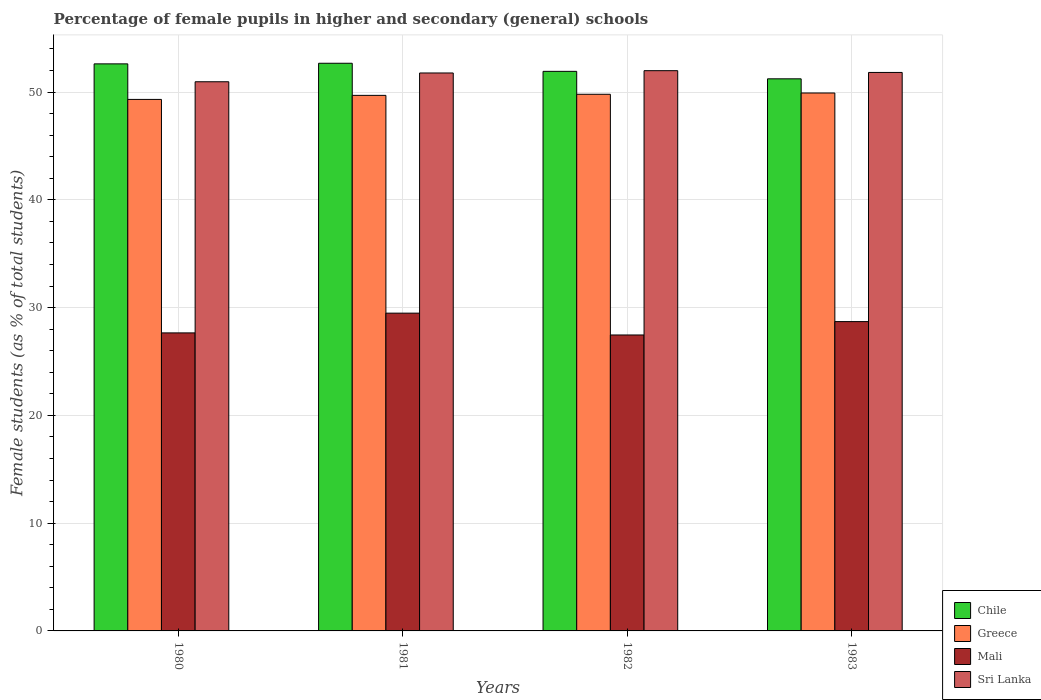How many groups of bars are there?
Ensure brevity in your answer.  4. Are the number of bars per tick equal to the number of legend labels?
Give a very brief answer. Yes. How many bars are there on the 1st tick from the left?
Offer a very short reply. 4. What is the percentage of female pupils in higher and secondary schools in Chile in 1980?
Offer a very short reply. 52.62. Across all years, what is the maximum percentage of female pupils in higher and secondary schools in Mali?
Your answer should be compact. 29.49. Across all years, what is the minimum percentage of female pupils in higher and secondary schools in Mali?
Provide a short and direct response. 27.46. In which year was the percentage of female pupils in higher and secondary schools in Sri Lanka minimum?
Your response must be concise. 1980. What is the total percentage of female pupils in higher and secondary schools in Greece in the graph?
Provide a succinct answer. 198.72. What is the difference between the percentage of female pupils in higher and secondary schools in Chile in 1981 and that in 1983?
Provide a short and direct response. 1.44. What is the difference between the percentage of female pupils in higher and secondary schools in Sri Lanka in 1981 and the percentage of female pupils in higher and secondary schools in Mali in 1980?
Your answer should be compact. 24.12. What is the average percentage of female pupils in higher and secondary schools in Chile per year?
Make the answer very short. 52.11. In the year 1983, what is the difference between the percentage of female pupils in higher and secondary schools in Mali and percentage of female pupils in higher and secondary schools in Sri Lanka?
Give a very brief answer. -23.12. What is the ratio of the percentage of female pupils in higher and secondary schools in Sri Lanka in 1981 to that in 1983?
Provide a succinct answer. 1. Is the percentage of female pupils in higher and secondary schools in Chile in 1982 less than that in 1983?
Your answer should be compact. No. Is the difference between the percentage of female pupils in higher and secondary schools in Mali in 1980 and 1983 greater than the difference between the percentage of female pupils in higher and secondary schools in Sri Lanka in 1980 and 1983?
Offer a very short reply. No. What is the difference between the highest and the second highest percentage of female pupils in higher and secondary schools in Sri Lanka?
Provide a short and direct response. 0.16. What is the difference between the highest and the lowest percentage of female pupils in higher and secondary schools in Sri Lanka?
Provide a succinct answer. 1.03. In how many years, is the percentage of female pupils in higher and secondary schools in Greece greater than the average percentage of female pupils in higher and secondary schools in Greece taken over all years?
Provide a short and direct response. 3. Is the sum of the percentage of female pupils in higher and secondary schools in Sri Lanka in 1981 and 1982 greater than the maximum percentage of female pupils in higher and secondary schools in Chile across all years?
Your answer should be very brief. Yes. Is it the case that in every year, the sum of the percentage of female pupils in higher and secondary schools in Sri Lanka and percentage of female pupils in higher and secondary schools in Greece is greater than the sum of percentage of female pupils in higher and secondary schools in Mali and percentage of female pupils in higher and secondary schools in Chile?
Provide a succinct answer. No. What does the 2nd bar from the left in 1983 represents?
Make the answer very short. Greece. What does the 2nd bar from the right in 1982 represents?
Keep it short and to the point. Mali. Is it the case that in every year, the sum of the percentage of female pupils in higher and secondary schools in Chile and percentage of female pupils in higher and secondary schools in Mali is greater than the percentage of female pupils in higher and secondary schools in Sri Lanka?
Your response must be concise. Yes. Are all the bars in the graph horizontal?
Make the answer very short. No. How many years are there in the graph?
Make the answer very short. 4. Where does the legend appear in the graph?
Your answer should be compact. Bottom right. How are the legend labels stacked?
Make the answer very short. Vertical. What is the title of the graph?
Ensure brevity in your answer.  Percentage of female pupils in higher and secondary (general) schools. Does "High income" appear as one of the legend labels in the graph?
Provide a succinct answer. No. What is the label or title of the X-axis?
Your answer should be very brief. Years. What is the label or title of the Y-axis?
Ensure brevity in your answer.  Female students (as % of total students). What is the Female students (as % of total students) of Chile in 1980?
Offer a very short reply. 52.62. What is the Female students (as % of total students) in Greece in 1980?
Your answer should be very brief. 49.32. What is the Female students (as % of total students) in Mali in 1980?
Provide a succinct answer. 27.65. What is the Female students (as % of total students) in Sri Lanka in 1980?
Offer a very short reply. 50.96. What is the Female students (as % of total students) in Chile in 1981?
Ensure brevity in your answer.  52.67. What is the Female students (as % of total students) of Greece in 1981?
Ensure brevity in your answer.  49.69. What is the Female students (as % of total students) of Mali in 1981?
Your answer should be very brief. 29.49. What is the Female students (as % of total students) of Sri Lanka in 1981?
Offer a very short reply. 51.77. What is the Female students (as % of total students) in Chile in 1982?
Provide a succinct answer. 51.92. What is the Female students (as % of total students) in Greece in 1982?
Offer a very short reply. 49.8. What is the Female students (as % of total students) in Mali in 1982?
Keep it short and to the point. 27.46. What is the Female students (as % of total students) of Sri Lanka in 1982?
Offer a very short reply. 51.98. What is the Female students (as % of total students) in Chile in 1983?
Keep it short and to the point. 51.23. What is the Female students (as % of total students) in Greece in 1983?
Offer a very short reply. 49.91. What is the Female students (as % of total students) of Mali in 1983?
Offer a very short reply. 28.7. What is the Female students (as % of total students) of Sri Lanka in 1983?
Provide a short and direct response. 51.82. Across all years, what is the maximum Female students (as % of total students) of Chile?
Ensure brevity in your answer.  52.67. Across all years, what is the maximum Female students (as % of total students) in Greece?
Keep it short and to the point. 49.91. Across all years, what is the maximum Female students (as % of total students) in Mali?
Your answer should be compact. 29.49. Across all years, what is the maximum Female students (as % of total students) in Sri Lanka?
Offer a very short reply. 51.98. Across all years, what is the minimum Female students (as % of total students) of Chile?
Provide a short and direct response. 51.23. Across all years, what is the minimum Female students (as % of total students) of Greece?
Your response must be concise. 49.32. Across all years, what is the minimum Female students (as % of total students) in Mali?
Ensure brevity in your answer.  27.46. Across all years, what is the minimum Female students (as % of total students) in Sri Lanka?
Make the answer very short. 50.96. What is the total Female students (as % of total students) in Chile in the graph?
Keep it short and to the point. 208.44. What is the total Female students (as % of total students) in Greece in the graph?
Provide a short and direct response. 198.72. What is the total Female students (as % of total students) of Mali in the graph?
Your answer should be compact. 113.3. What is the total Female students (as % of total students) in Sri Lanka in the graph?
Keep it short and to the point. 206.53. What is the difference between the Female students (as % of total students) of Chile in 1980 and that in 1981?
Your response must be concise. -0.06. What is the difference between the Female students (as % of total students) in Greece in 1980 and that in 1981?
Your answer should be compact. -0.38. What is the difference between the Female students (as % of total students) in Mali in 1980 and that in 1981?
Your answer should be very brief. -1.83. What is the difference between the Female students (as % of total students) in Sri Lanka in 1980 and that in 1981?
Keep it short and to the point. -0.81. What is the difference between the Female students (as % of total students) in Chile in 1980 and that in 1982?
Offer a terse response. 0.69. What is the difference between the Female students (as % of total students) in Greece in 1980 and that in 1982?
Offer a terse response. -0.48. What is the difference between the Female students (as % of total students) in Mali in 1980 and that in 1982?
Provide a short and direct response. 0.19. What is the difference between the Female students (as % of total students) of Sri Lanka in 1980 and that in 1982?
Your answer should be very brief. -1.03. What is the difference between the Female students (as % of total students) in Chile in 1980 and that in 1983?
Your answer should be compact. 1.39. What is the difference between the Female students (as % of total students) of Greece in 1980 and that in 1983?
Provide a succinct answer. -0.6. What is the difference between the Female students (as % of total students) in Mali in 1980 and that in 1983?
Ensure brevity in your answer.  -1.05. What is the difference between the Female students (as % of total students) in Sri Lanka in 1980 and that in 1983?
Keep it short and to the point. -0.86. What is the difference between the Female students (as % of total students) of Chile in 1981 and that in 1982?
Give a very brief answer. 0.75. What is the difference between the Female students (as % of total students) in Greece in 1981 and that in 1982?
Offer a very short reply. -0.1. What is the difference between the Female students (as % of total students) in Mali in 1981 and that in 1982?
Provide a short and direct response. 2.03. What is the difference between the Female students (as % of total students) in Sri Lanka in 1981 and that in 1982?
Offer a very short reply. -0.21. What is the difference between the Female students (as % of total students) of Chile in 1981 and that in 1983?
Offer a very short reply. 1.44. What is the difference between the Female students (as % of total students) of Greece in 1981 and that in 1983?
Make the answer very short. -0.22. What is the difference between the Female students (as % of total students) in Mali in 1981 and that in 1983?
Provide a short and direct response. 0.78. What is the difference between the Female students (as % of total students) in Sri Lanka in 1981 and that in 1983?
Provide a succinct answer. -0.05. What is the difference between the Female students (as % of total students) in Chile in 1982 and that in 1983?
Your answer should be very brief. 0.69. What is the difference between the Female students (as % of total students) of Greece in 1982 and that in 1983?
Provide a short and direct response. -0.12. What is the difference between the Female students (as % of total students) of Mali in 1982 and that in 1983?
Offer a very short reply. -1.24. What is the difference between the Female students (as % of total students) in Sri Lanka in 1982 and that in 1983?
Your answer should be very brief. 0.16. What is the difference between the Female students (as % of total students) of Chile in 1980 and the Female students (as % of total students) of Greece in 1981?
Your response must be concise. 2.92. What is the difference between the Female students (as % of total students) in Chile in 1980 and the Female students (as % of total students) in Mali in 1981?
Offer a terse response. 23.13. What is the difference between the Female students (as % of total students) of Chile in 1980 and the Female students (as % of total students) of Sri Lanka in 1981?
Your response must be concise. 0.85. What is the difference between the Female students (as % of total students) of Greece in 1980 and the Female students (as % of total students) of Mali in 1981?
Provide a short and direct response. 19.83. What is the difference between the Female students (as % of total students) of Greece in 1980 and the Female students (as % of total students) of Sri Lanka in 1981?
Ensure brevity in your answer.  -2.45. What is the difference between the Female students (as % of total students) in Mali in 1980 and the Female students (as % of total students) in Sri Lanka in 1981?
Your answer should be compact. -24.12. What is the difference between the Female students (as % of total students) of Chile in 1980 and the Female students (as % of total students) of Greece in 1982?
Provide a short and direct response. 2.82. What is the difference between the Female students (as % of total students) of Chile in 1980 and the Female students (as % of total students) of Mali in 1982?
Provide a succinct answer. 25.16. What is the difference between the Female students (as % of total students) in Chile in 1980 and the Female students (as % of total students) in Sri Lanka in 1982?
Give a very brief answer. 0.63. What is the difference between the Female students (as % of total students) of Greece in 1980 and the Female students (as % of total students) of Mali in 1982?
Keep it short and to the point. 21.86. What is the difference between the Female students (as % of total students) of Greece in 1980 and the Female students (as % of total students) of Sri Lanka in 1982?
Ensure brevity in your answer.  -2.67. What is the difference between the Female students (as % of total students) in Mali in 1980 and the Female students (as % of total students) in Sri Lanka in 1982?
Give a very brief answer. -24.33. What is the difference between the Female students (as % of total students) in Chile in 1980 and the Female students (as % of total students) in Greece in 1983?
Provide a succinct answer. 2.7. What is the difference between the Female students (as % of total students) of Chile in 1980 and the Female students (as % of total students) of Mali in 1983?
Your answer should be very brief. 23.91. What is the difference between the Female students (as % of total students) in Chile in 1980 and the Female students (as % of total students) in Sri Lanka in 1983?
Your response must be concise. 0.8. What is the difference between the Female students (as % of total students) in Greece in 1980 and the Female students (as % of total students) in Mali in 1983?
Make the answer very short. 20.62. What is the difference between the Female students (as % of total students) of Greece in 1980 and the Female students (as % of total students) of Sri Lanka in 1983?
Provide a short and direct response. -2.5. What is the difference between the Female students (as % of total students) in Mali in 1980 and the Female students (as % of total students) in Sri Lanka in 1983?
Your answer should be very brief. -24.17. What is the difference between the Female students (as % of total students) of Chile in 1981 and the Female students (as % of total students) of Greece in 1982?
Give a very brief answer. 2.88. What is the difference between the Female students (as % of total students) in Chile in 1981 and the Female students (as % of total students) in Mali in 1982?
Give a very brief answer. 25.21. What is the difference between the Female students (as % of total students) in Chile in 1981 and the Female students (as % of total students) in Sri Lanka in 1982?
Give a very brief answer. 0.69. What is the difference between the Female students (as % of total students) of Greece in 1981 and the Female students (as % of total students) of Mali in 1982?
Your answer should be very brief. 22.23. What is the difference between the Female students (as % of total students) of Greece in 1981 and the Female students (as % of total students) of Sri Lanka in 1982?
Keep it short and to the point. -2.29. What is the difference between the Female students (as % of total students) in Mali in 1981 and the Female students (as % of total students) in Sri Lanka in 1982?
Your answer should be very brief. -22.5. What is the difference between the Female students (as % of total students) of Chile in 1981 and the Female students (as % of total students) of Greece in 1983?
Provide a short and direct response. 2.76. What is the difference between the Female students (as % of total students) in Chile in 1981 and the Female students (as % of total students) in Mali in 1983?
Make the answer very short. 23.97. What is the difference between the Female students (as % of total students) in Chile in 1981 and the Female students (as % of total students) in Sri Lanka in 1983?
Give a very brief answer. 0.85. What is the difference between the Female students (as % of total students) of Greece in 1981 and the Female students (as % of total students) of Mali in 1983?
Your answer should be very brief. 20.99. What is the difference between the Female students (as % of total students) of Greece in 1981 and the Female students (as % of total students) of Sri Lanka in 1983?
Keep it short and to the point. -2.13. What is the difference between the Female students (as % of total students) of Mali in 1981 and the Female students (as % of total students) of Sri Lanka in 1983?
Make the answer very short. -22.34. What is the difference between the Female students (as % of total students) of Chile in 1982 and the Female students (as % of total students) of Greece in 1983?
Offer a terse response. 2.01. What is the difference between the Female students (as % of total students) in Chile in 1982 and the Female students (as % of total students) in Mali in 1983?
Ensure brevity in your answer.  23.22. What is the difference between the Female students (as % of total students) in Chile in 1982 and the Female students (as % of total students) in Sri Lanka in 1983?
Make the answer very short. 0.1. What is the difference between the Female students (as % of total students) in Greece in 1982 and the Female students (as % of total students) in Mali in 1983?
Give a very brief answer. 21.09. What is the difference between the Female students (as % of total students) in Greece in 1982 and the Female students (as % of total students) in Sri Lanka in 1983?
Provide a short and direct response. -2.03. What is the difference between the Female students (as % of total students) in Mali in 1982 and the Female students (as % of total students) in Sri Lanka in 1983?
Ensure brevity in your answer.  -24.36. What is the average Female students (as % of total students) of Chile per year?
Your response must be concise. 52.11. What is the average Female students (as % of total students) in Greece per year?
Provide a succinct answer. 49.68. What is the average Female students (as % of total students) of Mali per year?
Offer a terse response. 28.33. What is the average Female students (as % of total students) of Sri Lanka per year?
Your answer should be very brief. 51.63. In the year 1980, what is the difference between the Female students (as % of total students) in Chile and Female students (as % of total students) in Greece?
Your answer should be very brief. 3.3. In the year 1980, what is the difference between the Female students (as % of total students) in Chile and Female students (as % of total students) in Mali?
Keep it short and to the point. 24.96. In the year 1980, what is the difference between the Female students (as % of total students) of Chile and Female students (as % of total students) of Sri Lanka?
Offer a very short reply. 1.66. In the year 1980, what is the difference between the Female students (as % of total students) in Greece and Female students (as % of total students) in Mali?
Offer a terse response. 21.66. In the year 1980, what is the difference between the Female students (as % of total students) in Greece and Female students (as % of total students) in Sri Lanka?
Provide a succinct answer. -1.64. In the year 1980, what is the difference between the Female students (as % of total students) in Mali and Female students (as % of total students) in Sri Lanka?
Offer a terse response. -23.3. In the year 1981, what is the difference between the Female students (as % of total students) of Chile and Female students (as % of total students) of Greece?
Your response must be concise. 2.98. In the year 1981, what is the difference between the Female students (as % of total students) in Chile and Female students (as % of total students) in Mali?
Your answer should be compact. 23.19. In the year 1981, what is the difference between the Female students (as % of total students) of Chile and Female students (as % of total students) of Sri Lanka?
Provide a succinct answer. 0.9. In the year 1981, what is the difference between the Female students (as % of total students) in Greece and Female students (as % of total students) in Mali?
Your answer should be compact. 20.21. In the year 1981, what is the difference between the Female students (as % of total students) in Greece and Female students (as % of total students) in Sri Lanka?
Provide a succinct answer. -2.08. In the year 1981, what is the difference between the Female students (as % of total students) of Mali and Female students (as % of total students) of Sri Lanka?
Ensure brevity in your answer.  -22.28. In the year 1982, what is the difference between the Female students (as % of total students) of Chile and Female students (as % of total students) of Greece?
Offer a terse response. 2.13. In the year 1982, what is the difference between the Female students (as % of total students) in Chile and Female students (as % of total students) in Mali?
Provide a succinct answer. 24.46. In the year 1982, what is the difference between the Female students (as % of total students) in Chile and Female students (as % of total students) in Sri Lanka?
Offer a very short reply. -0.06. In the year 1982, what is the difference between the Female students (as % of total students) of Greece and Female students (as % of total students) of Mali?
Keep it short and to the point. 22.33. In the year 1982, what is the difference between the Female students (as % of total students) of Greece and Female students (as % of total students) of Sri Lanka?
Provide a succinct answer. -2.19. In the year 1982, what is the difference between the Female students (as % of total students) in Mali and Female students (as % of total students) in Sri Lanka?
Keep it short and to the point. -24.52. In the year 1983, what is the difference between the Female students (as % of total students) of Chile and Female students (as % of total students) of Greece?
Offer a very short reply. 1.31. In the year 1983, what is the difference between the Female students (as % of total students) in Chile and Female students (as % of total students) in Mali?
Your answer should be very brief. 22.53. In the year 1983, what is the difference between the Female students (as % of total students) in Chile and Female students (as % of total students) in Sri Lanka?
Provide a short and direct response. -0.59. In the year 1983, what is the difference between the Female students (as % of total students) of Greece and Female students (as % of total students) of Mali?
Your answer should be very brief. 21.21. In the year 1983, what is the difference between the Female students (as % of total students) in Greece and Female students (as % of total students) in Sri Lanka?
Your answer should be compact. -1.91. In the year 1983, what is the difference between the Female students (as % of total students) in Mali and Female students (as % of total students) in Sri Lanka?
Give a very brief answer. -23.12. What is the ratio of the Female students (as % of total students) in Chile in 1980 to that in 1981?
Provide a succinct answer. 1. What is the ratio of the Female students (as % of total students) of Greece in 1980 to that in 1981?
Give a very brief answer. 0.99. What is the ratio of the Female students (as % of total students) in Mali in 1980 to that in 1981?
Your response must be concise. 0.94. What is the ratio of the Female students (as % of total students) in Sri Lanka in 1980 to that in 1981?
Your response must be concise. 0.98. What is the ratio of the Female students (as % of total students) of Chile in 1980 to that in 1982?
Your answer should be compact. 1.01. What is the ratio of the Female students (as % of total students) of Mali in 1980 to that in 1982?
Keep it short and to the point. 1.01. What is the ratio of the Female students (as % of total students) of Sri Lanka in 1980 to that in 1982?
Your answer should be compact. 0.98. What is the ratio of the Female students (as % of total students) of Chile in 1980 to that in 1983?
Keep it short and to the point. 1.03. What is the ratio of the Female students (as % of total students) of Mali in 1980 to that in 1983?
Ensure brevity in your answer.  0.96. What is the ratio of the Female students (as % of total students) of Sri Lanka in 1980 to that in 1983?
Offer a terse response. 0.98. What is the ratio of the Female students (as % of total students) in Chile in 1981 to that in 1982?
Your answer should be very brief. 1.01. What is the ratio of the Female students (as % of total students) in Greece in 1981 to that in 1982?
Provide a succinct answer. 1. What is the ratio of the Female students (as % of total students) in Mali in 1981 to that in 1982?
Offer a terse response. 1.07. What is the ratio of the Female students (as % of total students) of Sri Lanka in 1981 to that in 1982?
Offer a terse response. 1. What is the ratio of the Female students (as % of total students) in Chile in 1981 to that in 1983?
Give a very brief answer. 1.03. What is the ratio of the Female students (as % of total students) in Greece in 1981 to that in 1983?
Your answer should be very brief. 1. What is the ratio of the Female students (as % of total students) in Mali in 1981 to that in 1983?
Provide a short and direct response. 1.03. What is the ratio of the Female students (as % of total students) of Chile in 1982 to that in 1983?
Keep it short and to the point. 1.01. What is the ratio of the Female students (as % of total students) of Greece in 1982 to that in 1983?
Provide a short and direct response. 1. What is the ratio of the Female students (as % of total students) of Mali in 1982 to that in 1983?
Your response must be concise. 0.96. What is the difference between the highest and the second highest Female students (as % of total students) of Chile?
Offer a terse response. 0.06. What is the difference between the highest and the second highest Female students (as % of total students) in Greece?
Offer a terse response. 0.12. What is the difference between the highest and the second highest Female students (as % of total students) in Mali?
Offer a terse response. 0.78. What is the difference between the highest and the second highest Female students (as % of total students) in Sri Lanka?
Make the answer very short. 0.16. What is the difference between the highest and the lowest Female students (as % of total students) in Chile?
Keep it short and to the point. 1.44. What is the difference between the highest and the lowest Female students (as % of total students) of Greece?
Keep it short and to the point. 0.6. What is the difference between the highest and the lowest Female students (as % of total students) of Mali?
Make the answer very short. 2.03. What is the difference between the highest and the lowest Female students (as % of total students) of Sri Lanka?
Your answer should be very brief. 1.03. 